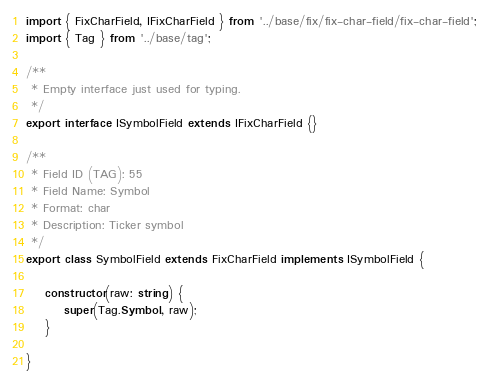Convert code to text. <code><loc_0><loc_0><loc_500><loc_500><_TypeScript_>import { FixCharField, IFixCharField } from '../base/fix/fix-char-field/fix-char-field';
import { Tag } from '../base/tag';

/**
 * Empty interface just used for typing.
 */
export interface ISymbolField extends IFixCharField {}

/**
 * Field ID (TAG): 55
 * Field Name: Symbol
 * Format: char
 * Description: Ticker symbol
 */
export class SymbolField extends FixCharField implements ISymbolField {

    constructor(raw: string) {
        super(Tag.Symbol, raw);
    }

}
</code> 